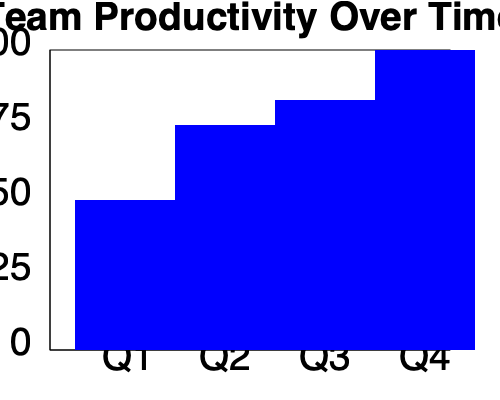As a team leader, you want to analyze your team's productivity trend over the past year. Based on the bar graph showing team productivity for each quarter, what conclusion can you draw about the team's performance, and how would you encourage the team to present these findings confidently? To analyze the team's productivity trend and encourage confident presentation of findings, follow these steps:

1. Observe the trend:
   - Q1: Productivity at 50 units
   - Q2: Productivity increases to 75 units
   - Q3: Productivity rises to 83 units
   - Q4: Productivity reaches 100 units

2. Identify the pattern:
   The graph shows a consistent upward trend in productivity across all four quarters.

3. Calculate the overall improvement:
   - Starting point: 50 units (Q1)
   - Ending point: 100 units (Q4)
   - Total improvement: 100 - 50 = 50 units
   - Percentage improvement: (50 / 50) * 100 = 100% increase

4. Recognize team achievements:
   - Consistent quarter-over-quarter growth
   - Doubling of productivity over the year

5. Encourage confident presentation:
   - Highlight the team's success in achieving continuous improvement
   - Emphasize the significant 100% increase in productivity
   - Encourage team members to share specific strategies or innovations that contributed to this growth

6. Conclusion:
   The team has demonstrated exceptional performance with steady growth and a doubling of productivity over the year.
Answer: Consistent growth, 100% productivity increase; encourage team to confidently present strategies behind success. 